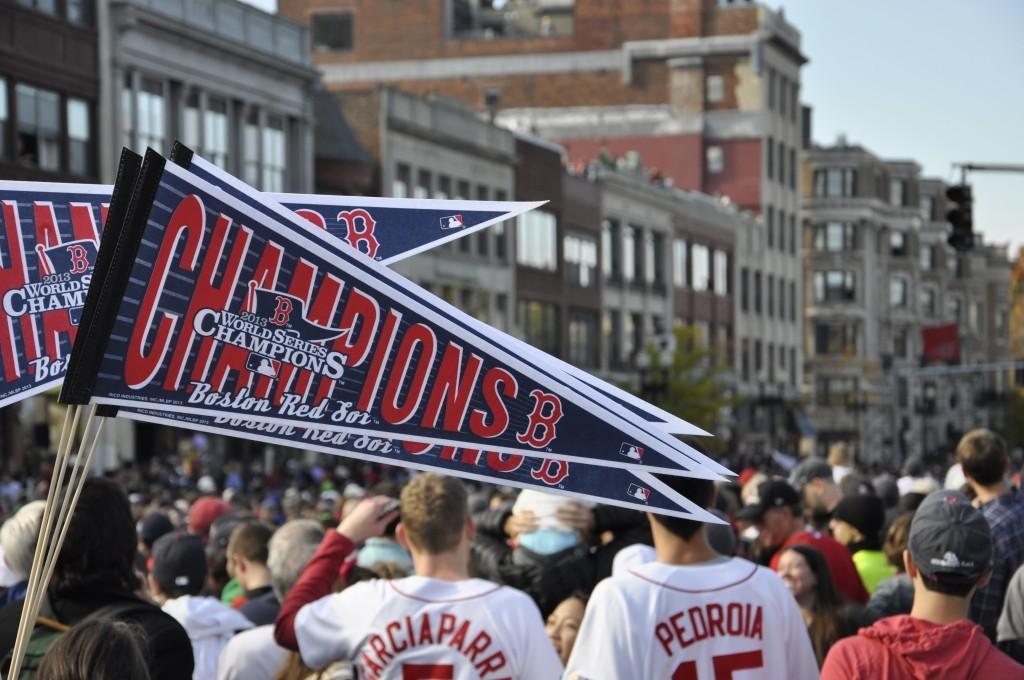What team are the flags for?
Offer a very short reply. Boston red sox. 